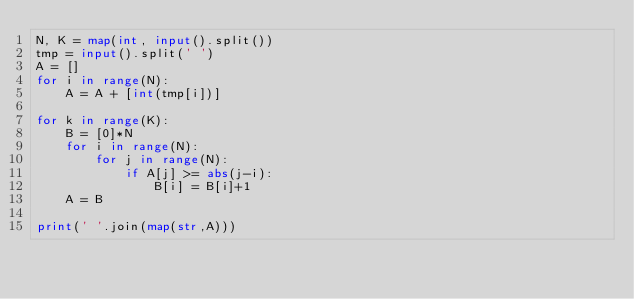Convert code to text. <code><loc_0><loc_0><loc_500><loc_500><_Python_>N, K = map(int, input().split())
tmp = input().split(' ')
A = []
for i in range(N):
    A = A + [int(tmp[i])]

for k in range(K):
    B = [0]*N
    for i in range(N):
        for j in range(N):
            if A[j] >= abs(j-i):
                B[i] = B[i]+1
    A = B

print(' '.join(map(str,A)))</code> 